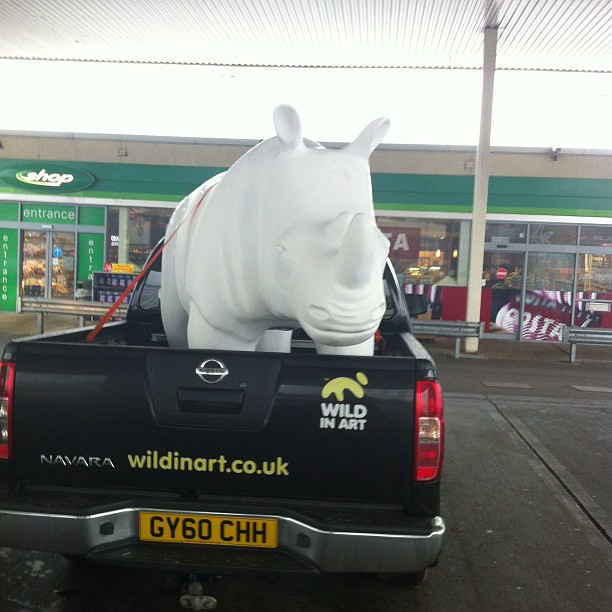Please transcribe the text in this image. NAVARA wildinart.co.uk WILD IN ART CHH GY60 A untra entrance entrance 